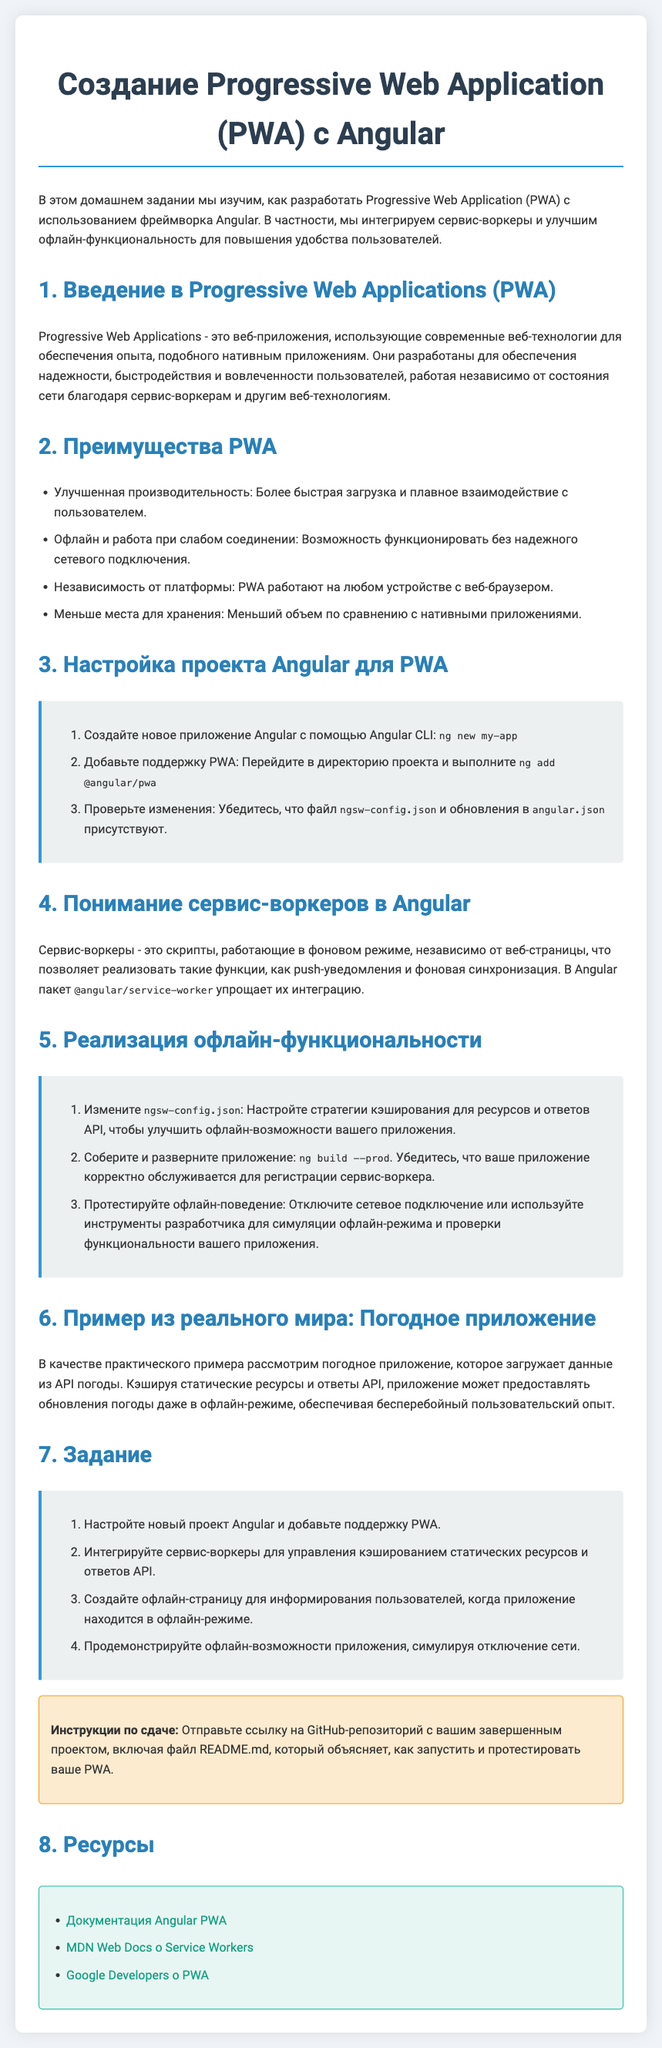what is the title of the homework? The title of the homework is found in the document's heading.
Answer: Создание Progressive Web Application (PWA) с Angular what command is used to create a new Angular application? The command to create a new Angular application is mentioned in the setup section.
Answer: ng new my-app what is one advantage of using PWA? One advantage of using PWA is listed in the benefits section of the document.
Answer: Улучшенная производительность how many tasks are listed in the implementation section? The document includes a numbered list of tasks for implementation.
Answer: 3 what is the purpose of service workers in Angular? The purpose of service workers is explained in the respective section of the document.
Answer: Реализация таких функций, как push-уведомления и фоновая синхронизация what should you submit after completing the assignment? The submission instructions specify what to include.
Answer: Ссылка на GitHub-репозиторий what is an example of a real-world application mentioned in the document? The document provides a specific example in the real-world section.
Answer: Погодное приложение what is the color of the task section background? The background color of the task section is described in the styles of the document.
Answer: #ecf0f1 